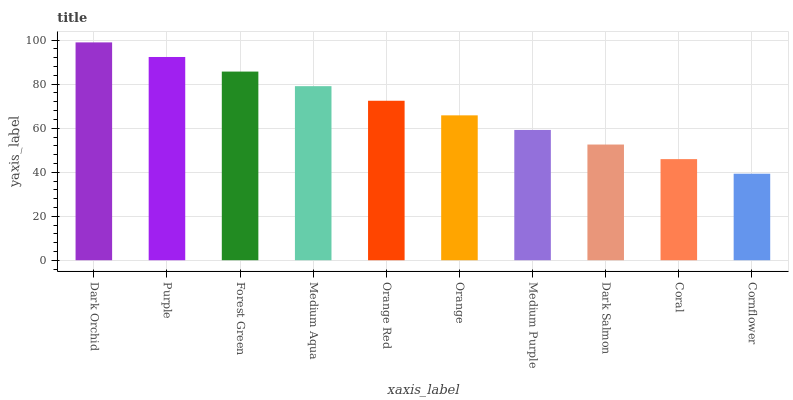Is Cornflower the minimum?
Answer yes or no. Yes. Is Dark Orchid the maximum?
Answer yes or no. Yes. Is Purple the minimum?
Answer yes or no. No. Is Purple the maximum?
Answer yes or no. No. Is Dark Orchid greater than Purple?
Answer yes or no. Yes. Is Purple less than Dark Orchid?
Answer yes or no. Yes. Is Purple greater than Dark Orchid?
Answer yes or no. No. Is Dark Orchid less than Purple?
Answer yes or no. No. Is Orange Red the high median?
Answer yes or no. Yes. Is Orange the low median?
Answer yes or no. Yes. Is Dark Orchid the high median?
Answer yes or no. No. Is Medium Aqua the low median?
Answer yes or no. No. 